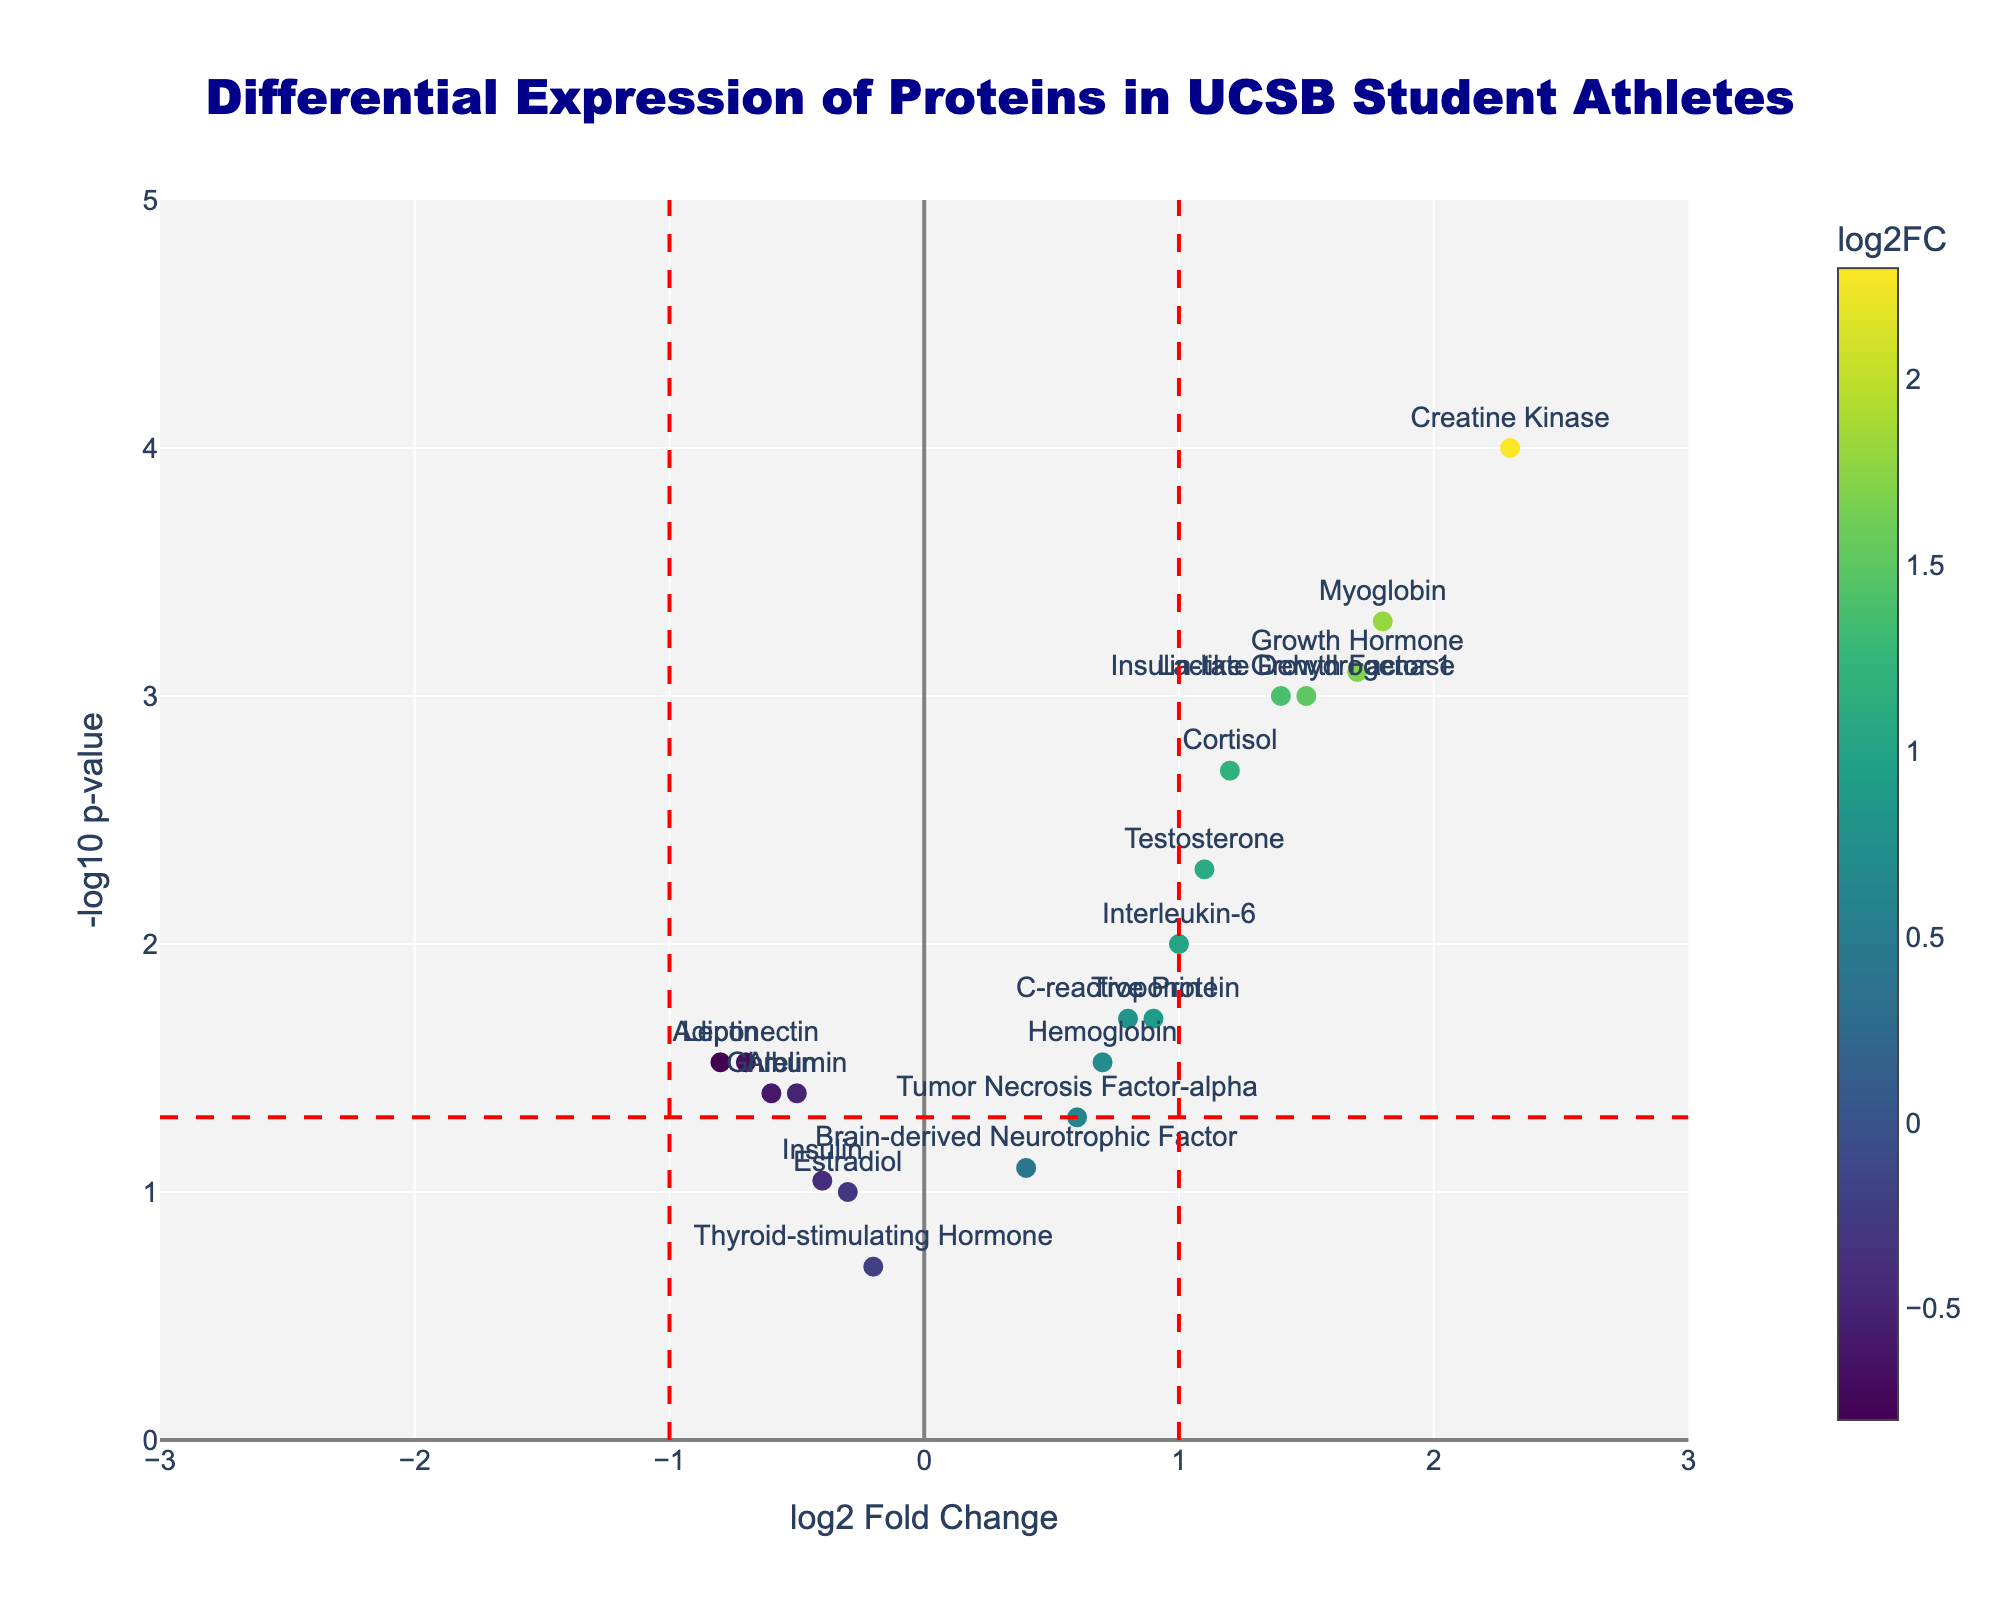How many vertical dashed lines are in the plot? There are 2 vertical dashed lines at log2FC values of -1 and 1, representing thresholds for significant fold changes.
Answer: 2 What does the x-axis represent? The x-axis represents the log2 Fold Change (log2FC) of protein expression between UCSB student athletes and non-athletes.
Answer: log2 Fold Change Which protein has the highest log2 Fold Change? The protein with the highest log2 Fold Change is Creatine Kinase. This can be identified by locating the data point farthest to the right on the x-axis.
Answer: Creatine Kinase Which protein has the most statistically significant change in expression? The protein with the most statistically significant change in expression has the lowest p-value, which corresponds to the highest -log10 p-value on the y-axis. This is Creatine Kinase.
Answer: Creatine Kinase What is the threshold for statistical significance on the y-axis? The threshold for statistical significance on the y-axis is indicated by the horizontal dashed line, which corresponds to a p-value of 0.05 or -log10(0.05) ≈ 1.3.
Answer: -log10(0.05) How many proteins are down-regulated with statistical significance? Down-regulated proteins have negative log2 Fold Change values. To be statistically significant, they must also have -log10 p-values above the horizontal threshold line. The proteins meeting both criteria are Albumin, Leptin, Ghrelin, and Adiponectin.
Answer: 4 What's the median log2 Fold Change value of the proteins? Organize the log2 Fold Change values in ascending order and find the middle value. The sorted values are: -0.8, -0.7, -0.6, -0.5, -0.4, -0.3, -0.2, 0.4, 0.6, 0.7, 0.8, 0.9, 1.0, 1.1, 1.2, 1.4, 1.5, 1.7, 1.8, 2.3. The median value is the average of the 10th and 11th values, which are 0.7 and 0.8. (0.7 + 0.8) / 2 = 0.75.
Answer: 0.75 What color represents a log2 Fold Change of 0? The color scale used in the plot is Viridis, and the color corresponding to a log2 Fold Change of 0, which is close to zero, is typically green.
Answer: Green Which protein has a log2 Fold Change of approximately 1.0 and is also statistically significant? Interleukin-6 has a log2 Fold Change of exactly 1.0 and a p-value less than 0.05, making it statistically significant.
Answer: Interleukin-6 